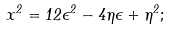Convert formula to latex. <formula><loc_0><loc_0><loc_500><loc_500>x ^ { 2 } = 1 2 \epsilon ^ { 2 } - 4 \eta \epsilon + \eta ^ { 2 } ;</formula> 